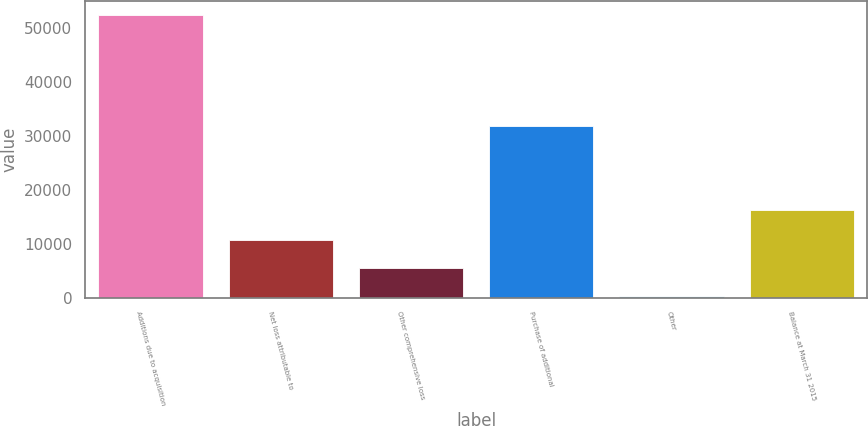<chart> <loc_0><loc_0><loc_500><loc_500><bar_chart><fcel>Additions due to acquisition<fcel>Net loss attributable to<fcel>Other comprehensive loss<fcel>Purchase of additional<fcel>Other<fcel>Balance at March 31 2015<nl><fcel>52467<fcel>10736.6<fcel>5520.3<fcel>31849<fcel>304<fcel>16372<nl></chart> 